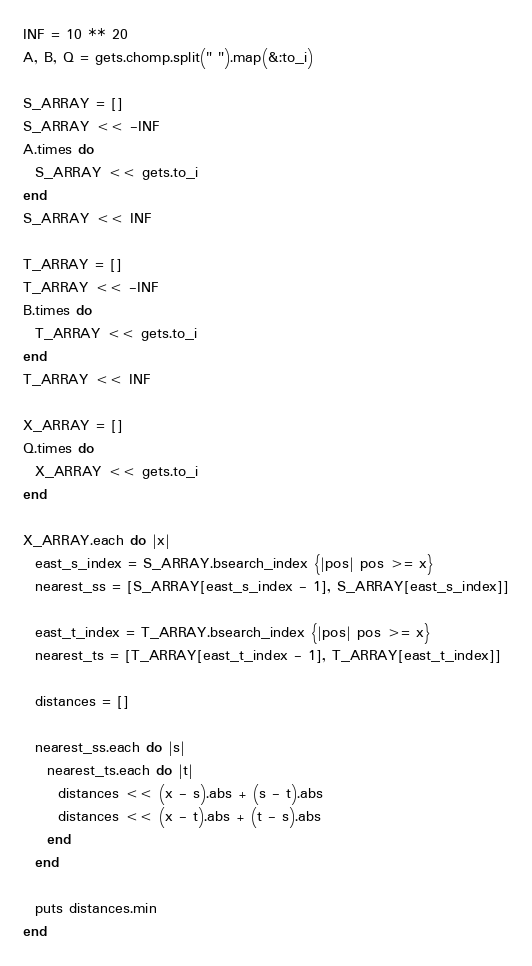Convert code to text. <code><loc_0><loc_0><loc_500><loc_500><_Ruby_>INF = 10 ** 20
A, B, Q = gets.chomp.split(" ").map(&:to_i)

S_ARRAY = []
S_ARRAY << -INF
A.times do
  S_ARRAY << gets.to_i
end
S_ARRAY << INF

T_ARRAY = []
T_ARRAY << -INF
B.times do
  T_ARRAY << gets.to_i
end
T_ARRAY << INF

X_ARRAY = []
Q.times do
  X_ARRAY << gets.to_i
end

X_ARRAY.each do |x|
  east_s_index = S_ARRAY.bsearch_index {|pos| pos >= x}
  nearest_ss = [S_ARRAY[east_s_index - 1], S_ARRAY[east_s_index]]

  east_t_index = T_ARRAY.bsearch_index {|pos| pos >= x}
  nearest_ts = [T_ARRAY[east_t_index - 1], T_ARRAY[east_t_index]]

  distances = []

  nearest_ss.each do |s|
    nearest_ts.each do |t|
      distances << (x - s).abs + (s - t).abs
      distances << (x - t).abs + (t - s).abs
    end
  end

  puts distances.min
end</code> 